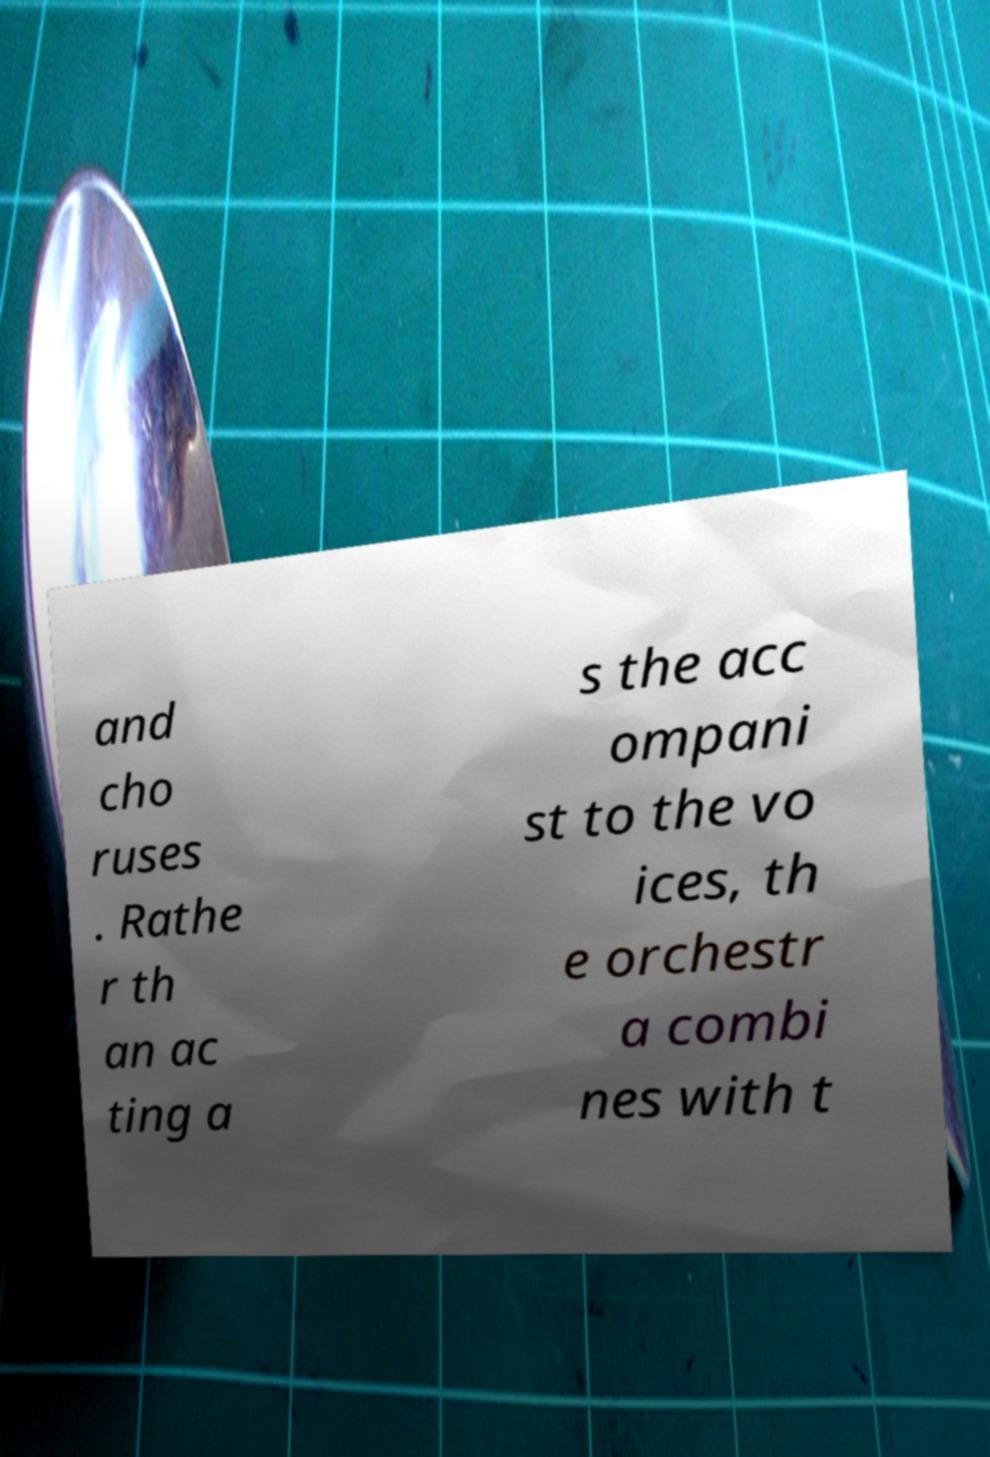Could you assist in decoding the text presented in this image and type it out clearly? and cho ruses . Rathe r th an ac ting a s the acc ompani st to the vo ices, th e orchestr a combi nes with t 